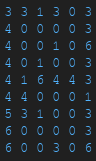Convert code to text. <code><loc_0><loc_0><loc_500><loc_500><_SQL_>3 3 1 3 0 3
4 0 0 0 0 3
4 0 0 1 0 6
4 0 1 0 0 3
4 1 6 4 4 3
4 4 0 0 0 1
5 3 1 0 0 3
6 0 0 0 0 3
6 0 0 3 0 6</code> 